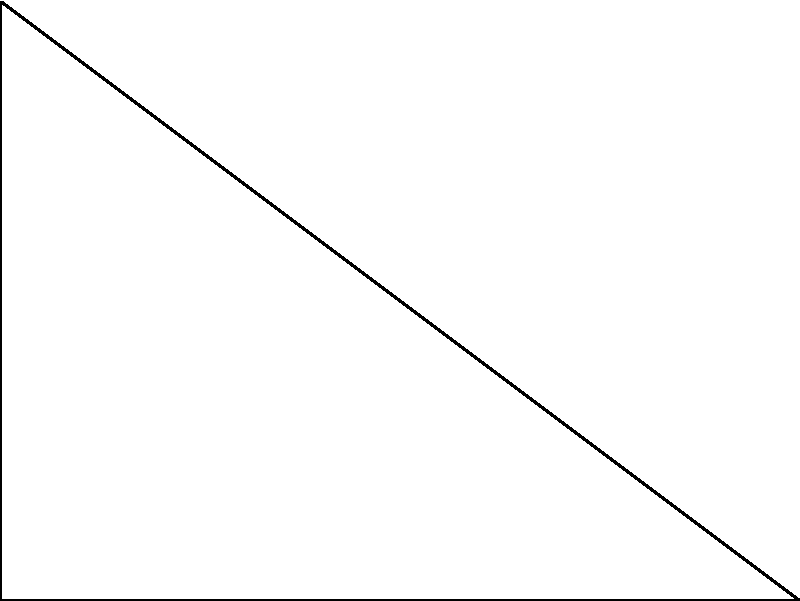In the diagram, a star's parallax angle $p$ is measured to be 0.5 arcseconds. Using the baseline distance of 1 AU between Earth's positions, calculate the distance $d$ to the star in parsecs. How might this precise measurement contribute to your strategic approach in game planning? To solve this problem, we'll use the definition of a parsec and the small angle approximation:

1. Definition of a parsec: 1 parsec is the distance at which an object has a parallax of 1 arcsecond when observed from points 1 AU apart.

2. The formula for distance in parsecs is:
   $d = \frac{1}{p}$, where $d$ is in parsecs and $p$ is in arcseconds

3. Given information:
   Parallax angle $p = 0.5$ arcseconds
   
4. Plug the value into the formula:
   $d = \frac{1}{0.5} = 2$ parsecs

5. Strategic implications:
   This precise measurement demonstrates the importance of accuracy in long-range observations. In football strategy, this could translate to the need for precise measurements in player positioning and play execution, especially for long-range plays or when analyzing opponents' tendencies from a distance.
Answer: 2 parsecs 